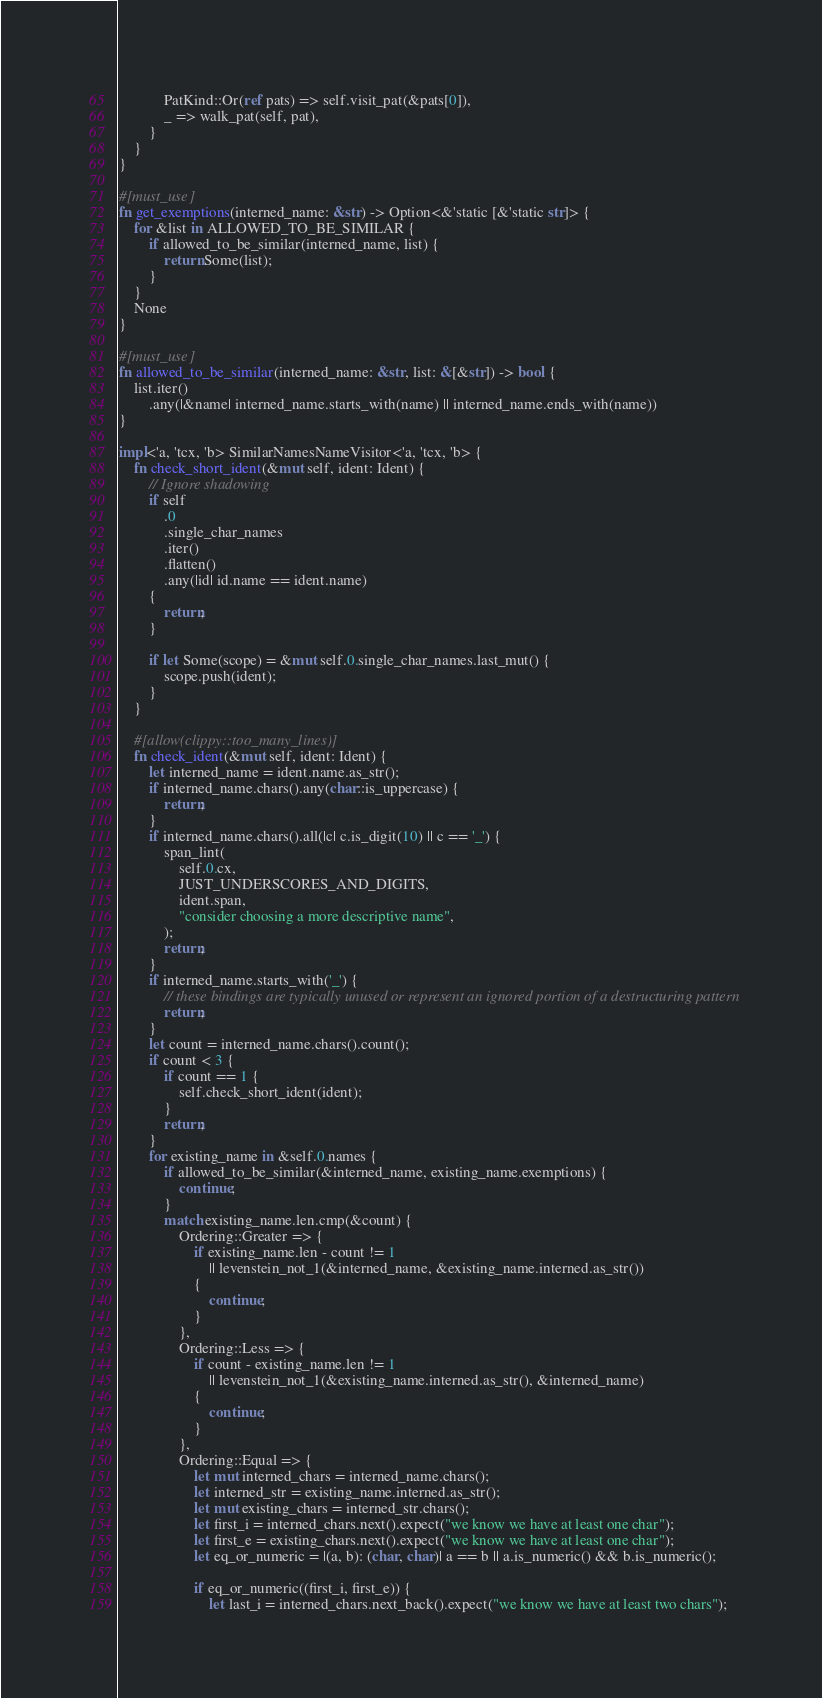Convert code to text. <code><loc_0><loc_0><loc_500><loc_500><_Rust_>            PatKind::Or(ref pats) => self.visit_pat(&pats[0]),
            _ => walk_pat(self, pat),
        }
    }
}

#[must_use]
fn get_exemptions(interned_name: &str) -> Option<&'static [&'static str]> {
    for &list in ALLOWED_TO_BE_SIMILAR {
        if allowed_to_be_similar(interned_name, list) {
            return Some(list);
        }
    }
    None
}

#[must_use]
fn allowed_to_be_similar(interned_name: &str, list: &[&str]) -> bool {
    list.iter()
        .any(|&name| interned_name.starts_with(name) || interned_name.ends_with(name))
}

impl<'a, 'tcx, 'b> SimilarNamesNameVisitor<'a, 'tcx, 'b> {
    fn check_short_ident(&mut self, ident: Ident) {
        // Ignore shadowing
        if self
            .0
            .single_char_names
            .iter()
            .flatten()
            .any(|id| id.name == ident.name)
        {
            return;
        }

        if let Some(scope) = &mut self.0.single_char_names.last_mut() {
            scope.push(ident);
        }
    }

    #[allow(clippy::too_many_lines)]
    fn check_ident(&mut self, ident: Ident) {
        let interned_name = ident.name.as_str();
        if interned_name.chars().any(char::is_uppercase) {
            return;
        }
        if interned_name.chars().all(|c| c.is_digit(10) || c == '_') {
            span_lint(
                self.0.cx,
                JUST_UNDERSCORES_AND_DIGITS,
                ident.span,
                "consider choosing a more descriptive name",
            );
            return;
        }
        if interned_name.starts_with('_') {
            // these bindings are typically unused or represent an ignored portion of a destructuring pattern
            return;
        }
        let count = interned_name.chars().count();
        if count < 3 {
            if count == 1 {
                self.check_short_ident(ident);
            }
            return;
        }
        for existing_name in &self.0.names {
            if allowed_to_be_similar(&interned_name, existing_name.exemptions) {
                continue;
            }
            match existing_name.len.cmp(&count) {
                Ordering::Greater => {
                    if existing_name.len - count != 1
                        || levenstein_not_1(&interned_name, &existing_name.interned.as_str())
                    {
                        continue;
                    }
                },
                Ordering::Less => {
                    if count - existing_name.len != 1
                        || levenstein_not_1(&existing_name.interned.as_str(), &interned_name)
                    {
                        continue;
                    }
                },
                Ordering::Equal => {
                    let mut interned_chars = interned_name.chars();
                    let interned_str = existing_name.interned.as_str();
                    let mut existing_chars = interned_str.chars();
                    let first_i = interned_chars.next().expect("we know we have at least one char");
                    let first_e = existing_chars.next().expect("we know we have at least one char");
                    let eq_or_numeric = |(a, b): (char, char)| a == b || a.is_numeric() && b.is_numeric();

                    if eq_or_numeric((first_i, first_e)) {
                        let last_i = interned_chars.next_back().expect("we know we have at least two chars");</code> 